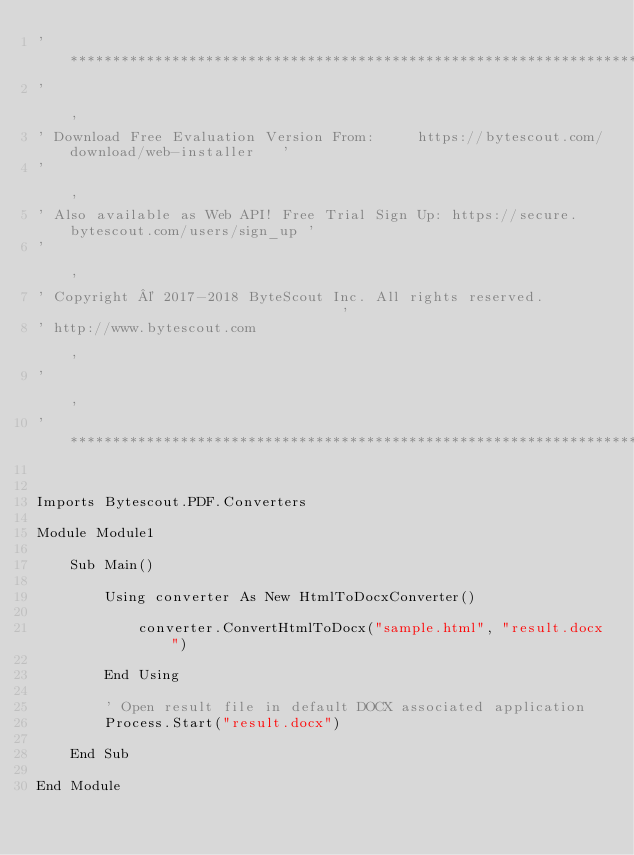Convert code to text. <code><loc_0><loc_0><loc_500><loc_500><_VisualBasic_>'*******************************************************************************************'
'                                                                                           '
' Download Free Evaluation Version From:     https://bytescout.com/download/web-installer   '
'                                                                                           '
' Also available as Web API! Free Trial Sign Up: https://secure.bytescout.com/users/sign_up '
'                                                                                           '
' Copyright © 2017-2018 ByteScout Inc. All rights reserved.                                 '
' http://www.bytescout.com                                                                  '
'                                                                                           '
'*******************************************************************************************'


Imports Bytescout.PDF.Converters

Module Module1

    Sub Main()

		Using converter As New HtmlToDocxConverter()

			converter.ConvertHtmlToDocx("sample.html", "result.docx")

		End Using

		' Open result file in default DOCX associated application
		Process.Start("result.docx")

    End Sub

End Module
</code> 